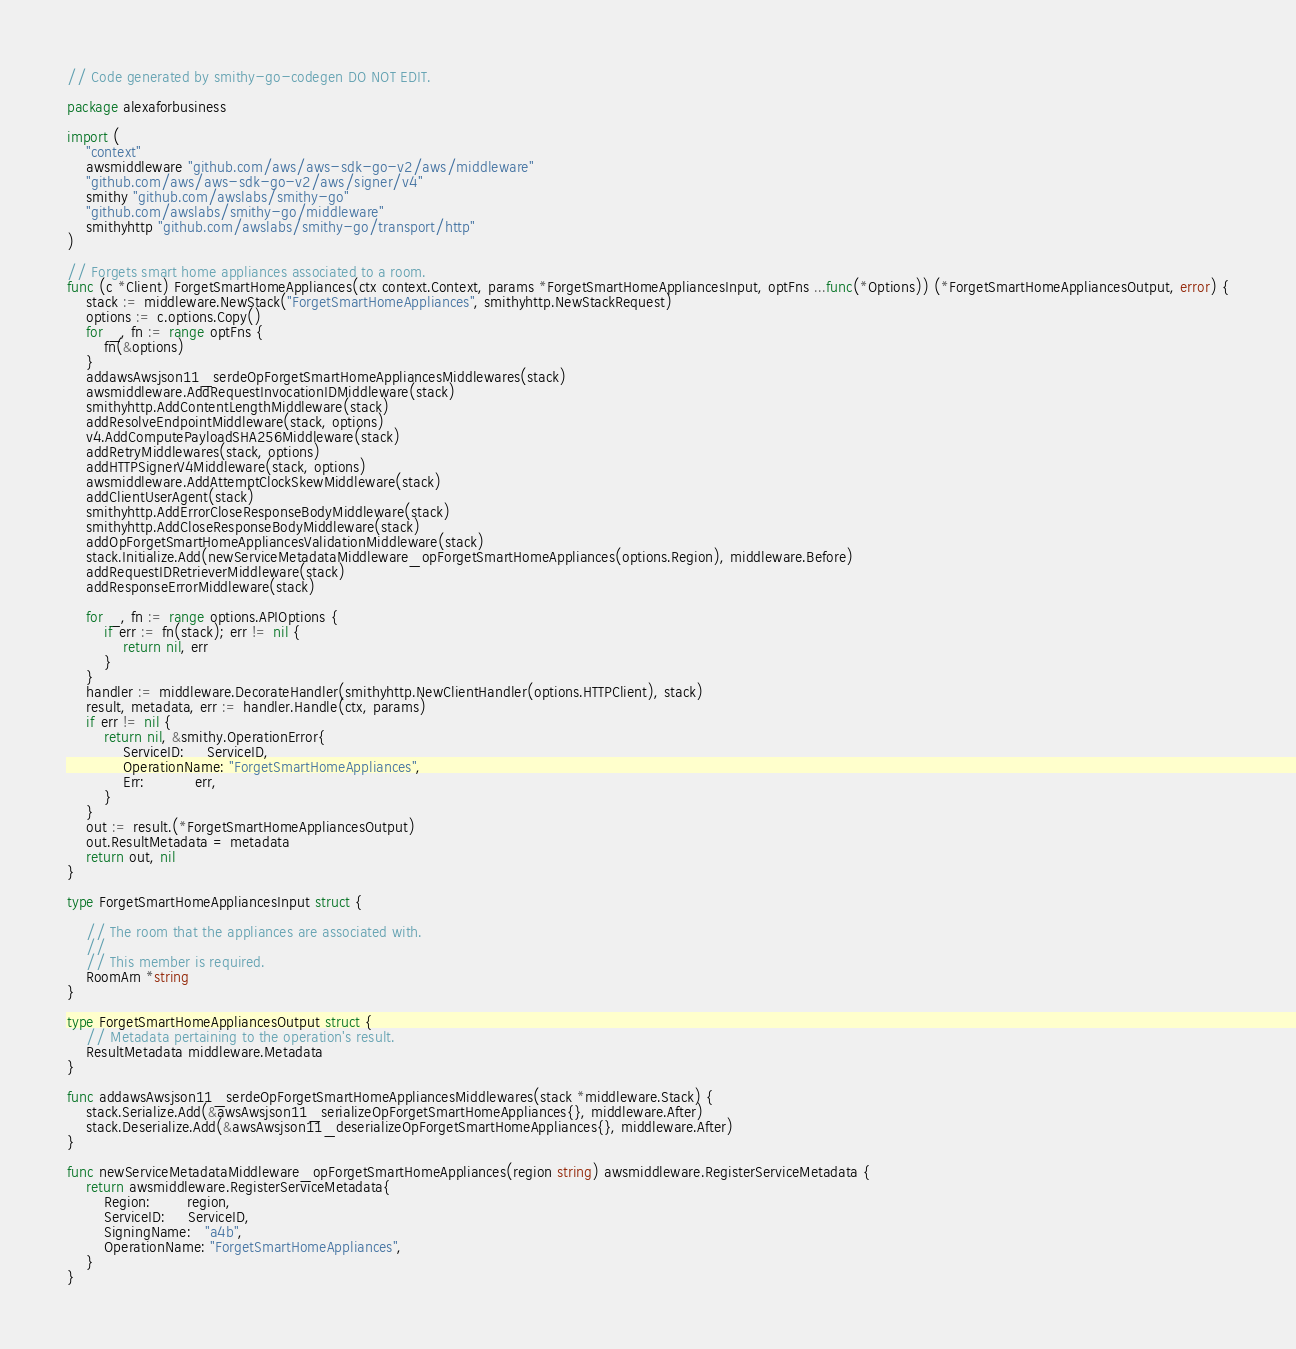Convert code to text. <code><loc_0><loc_0><loc_500><loc_500><_Go_>// Code generated by smithy-go-codegen DO NOT EDIT.

package alexaforbusiness

import (
	"context"
	awsmiddleware "github.com/aws/aws-sdk-go-v2/aws/middleware"
	"github.com/aws/aws-sdk-go-v2/aws/signer/v4"
	smithy "github.com/awslabs/smithy-go"
	"github.com/awslabs/smithy-go/middleware"
	smithyhttp "github.com/awslabs/smithy-go/transport/http"
)

// Forgets smart home appliances associated to a room.
func (c *Client) ForgetSmartHomeAppliances(ctx context.Context, params *ForgetSmartHomeAppliancesInput, optFns ...func(*Options)) (*ForgetSmartHomeAppliancesOutput, error) {
	stack := middleware.NewStack("ForgetSmartHomeAppliances", smithyhttp.NewStackRequest)
	options := c.options.Copy()
	for _, fn := range optFns {
		fn(&options)
	}
	addawsAwsjson11_serdeOpForgetSmartHomeAppliancesMiddlewares(stack)
	awsmiddleware.AddRequestInvocationIDMiddleware(stack)
	smithyhttp.AddContentLengthMiddleware(stack)
	addResolveEndpointMiddleware(stack, options)
	v4.AddComputePayloadSHA256Middleware(stack)
	addRetryMiddlewares(stack, options)
	addHTTPSignerV4Middleware(stack, options)
	awsmiddleware.AddAttemptClockSkewMiddleware(stack)
	addClientUserAgent(stack)
	smithyhttp.AddErrorCloseResponseBodyMiddleware(stack)
	smithyhttp.AddCloseResponseBodyMiddleware(stack)
	addOpForgetSmartHomeAppliancesValidationMiddleware(stack)
	stack.Initialize.Add(newServiceMetadataMiddleware_opForgetSmartHomeAppliances(options.Region), middleware.Before)
	addRequestIDRetrieverMiddleware(stack)
	addResponseErrorMiddleware(stack)

	for _, fn := range options.APIOptions {
		if err := fn(stack); err != nil {
			return nil, err
		}
	}
	handler := middleware.DecorateHandler(smithyhttp.NewClientHandler(options.HTTPClient), stack)
	result, metadata, err := handler.Handle(ctx, params)
	if err != nil {
		return nil, &smithy.OperationError{
			ServiceID:     ServiceID,
			OperationName: "ForgetSmartHomeAppliances",
			Err:           err,
		}
	}
	out := result.(*ForgetSmartHomeAppliancesOutput)
	out.ResultMetadata = metadata
	return out, nil
}

type ForgetSmartHomeAppliancesInput struct {

	// The room that the appliances are associated with.
	//
	// This member is required.
	RoomArn *string
}

type ForgetSmartHomeAppliancesOutput struct {
	// Metadata pertaining to the operation's result.
	ResultMetadata middleware.Metadata
}

func addawsAwsjson11_serdeOpForgetSmartHomeAppliancesMiddlewares(stack *middleware.Stack) {
	stack.Serialize.Add(&awsAwsjson11_serializeOpForgetSmartHomeAppliances{}, middleware.After)
	stack.Deserialize.Add(&awsAwsjson11_deserializeOpForgetSmartHomeAppliances{}, middleware.After)
}

func newServiceMetadataMiddleware_opForgetSmartHomeAppliances(region string) awsmiddleware.RegisterServiceMetadata {
	return awsmiddleware.RegisterServiceMetadata{
		Region:        region,
		ServiceID:     ServiceID,
		SigningName:   "a4b",
		OperationName: "ForgetSmartHomeAppliances",
	}
}
</code> 